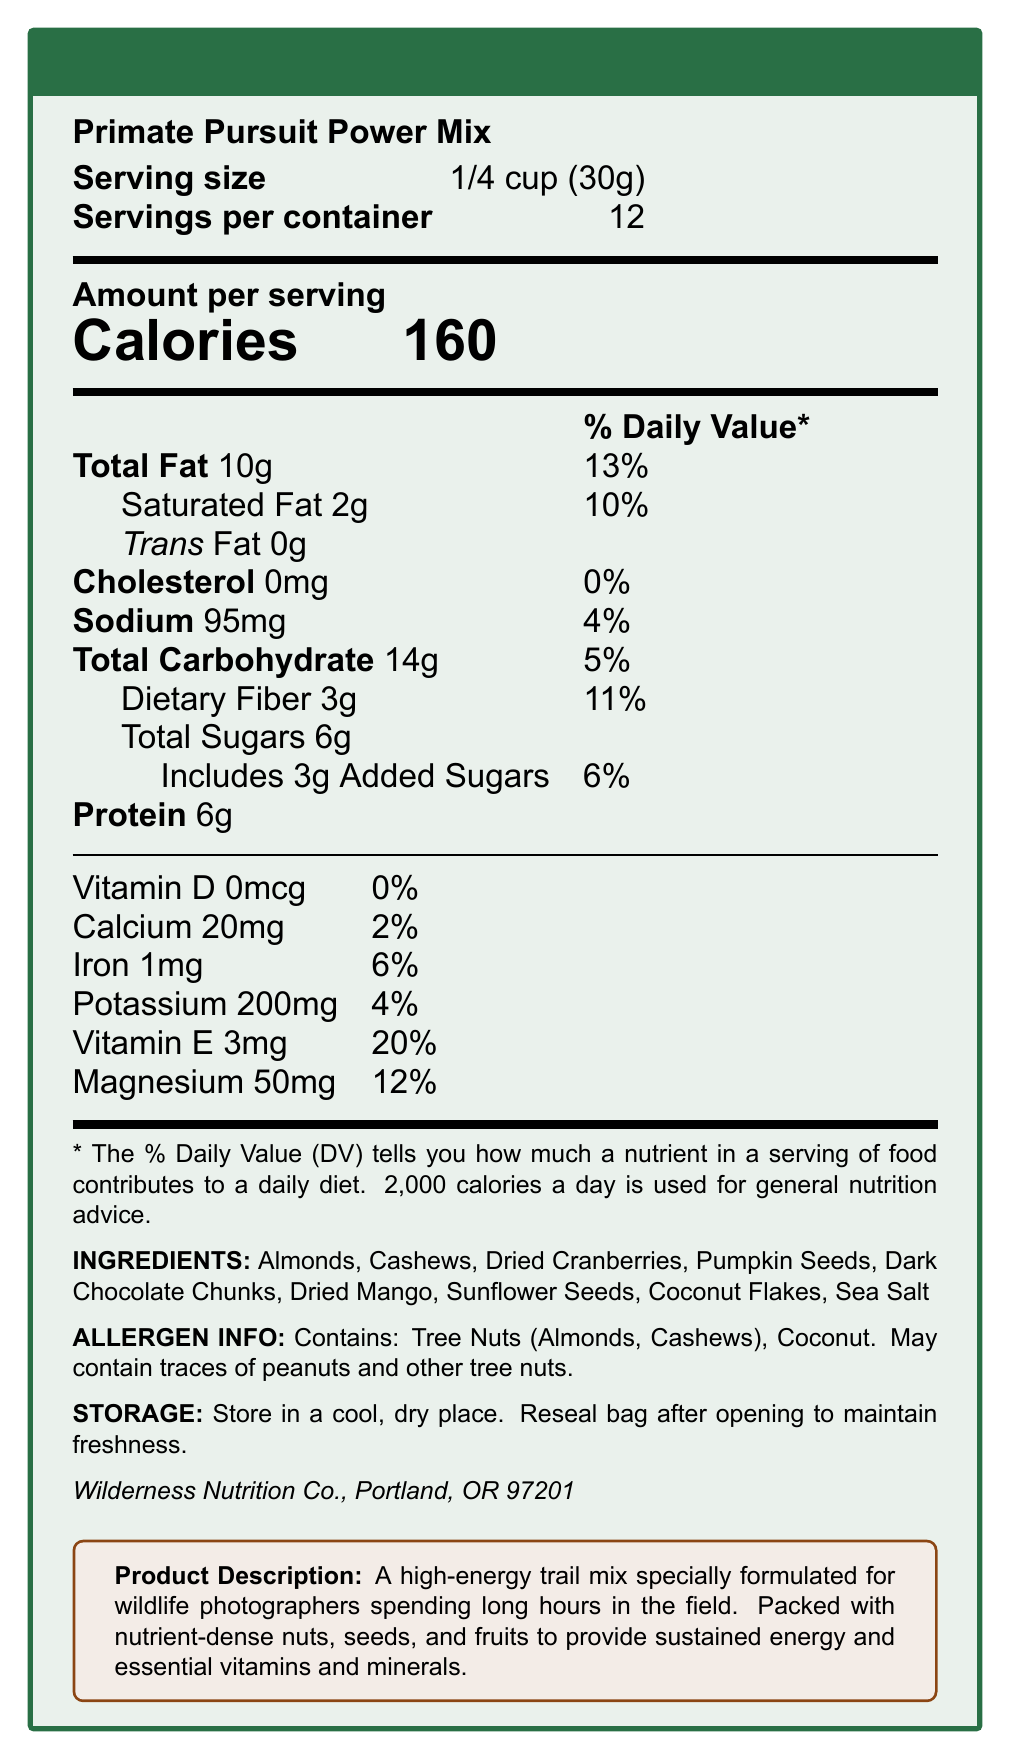What is the serving size for the Primate Pursuit Power Mix? The serving size is listed at the top of the nutritional information section as "Serving size: 1/4 cup (30g)".
Answer: 1/4 cup (30g) How many servings are there per container of Primate Pursuit Power Mix? The document states "Servings per container: 12" next to the serving size information.
Answer: 12 How many calories are in one serving of the Primate Pursuit Power Mix? The number of calories per serving is prominently displayed under "Amount per serving" with the label "Calories: 160".
Answer: 160 What is the total fat content per serving and its percentage of the daily value? Under the Total Fat section of the nutritional facts, it states "Total Fat 10g" and "13%" for the daily value.
Answer: 10g (13%) How much protein is there in one serving of the Primate Pursuit Power Mix? The protein content per serving is listed as "Protein 6g" in the nutritional information.
Answer: 6g Which vitamins and minerals are present in the Primate Pursuit Power Mix, and what percentages of the daily value do they provide? The nutritional facts section lists these vitamins and minerals with their amounts and respective daily values on the lower part of the document.
Answer: Vitamin D 0% (0mcg), Calcium 2% (20mg), Iron 6% (1mg), Potassium 4% (200mg), Vitamin E 20% (3mg), Magnesium 12% (50mg) What allergens are present in the Primate Pursuit Power Mix? The allergen information is detailed in a section which states "Contains: Tree Nuts (Almonds, Cashews), Coconut. May contain traces of peanuts and other tree nuts."
Answer: Tree Nuts (Almonds, Cashews), Coconut. May contain traces of peanuts and other tree nuts What storage instructions are given for the Primate Pursuit Power Mix? The storage instructions section specifies "Store in a cool, dry place. Reseal bag after opening to maintain freshness."
Answer: Store in a cool, dry place. Reseal bag after opening to maintain freshness. Which of the following ingredients is NOT found in the Primate Pursuit Power Mix? A. Almonds B. Raisins C. Pumpkin Seeds D. Dark Chocolate Chunks The ingredient list includes Almonds, Pumpkin Seeds, and Dark Chocolate Chunks, but not Raisins.
Answer: B What percentage of the daily value of saturated fat does one serving of the Primate Pursuit Power Mix provide? A. 2% B. 6% C. 10% D. 13% The nutrient section shows "Saturated Fat 2g" and "10%" for the daily value.
Answer: C Is there any cholesterol in the Primate Pursuit Power Mix? The document states "Cholesterol 0mg" under the nutritional information.
Answer: No Summarize the purpose and main content of the Primate Pursuit Power Mix document. The document is structured to inform the consumer about the nutritional content, ingredients, and usage instructions for the Primate Pursuit Power Mix.
Answer: The document provides nutritional information, ingredients, allergen details, storage instructions, and a description of the Primate Pursuit Power Mix, a high-energy trail mix designed for wildlife photographers. It highlights the serving size, servings per container, calorie count, and the amounts and daily values of various nutrients. It also lists the ingredients and potential allergens, along with storage instructions and manufacturer details. Where is the Wilderness Nutrition Co. located? The document provides the manufacturer details which state "Wilderness Nutrition Co., Portland, OR 97201".
Answer: Portland, OR 97201 Is there any information about the manufacturing date or expiration date for Primate Pursuit Power Mix? The document does not include any details about the manufacturing date or expiration date of the product.
Answer: Not enough information What are the total carbohydrate contents in one serving of Primate Pursuit Power Mix, and how much of this is dietary fiber? The nutritional information states "Total Carbohydrate 14g" and "Dietary Fiber 3g".
Answer: 14g total carbohydrates, 3g dietary fiber 